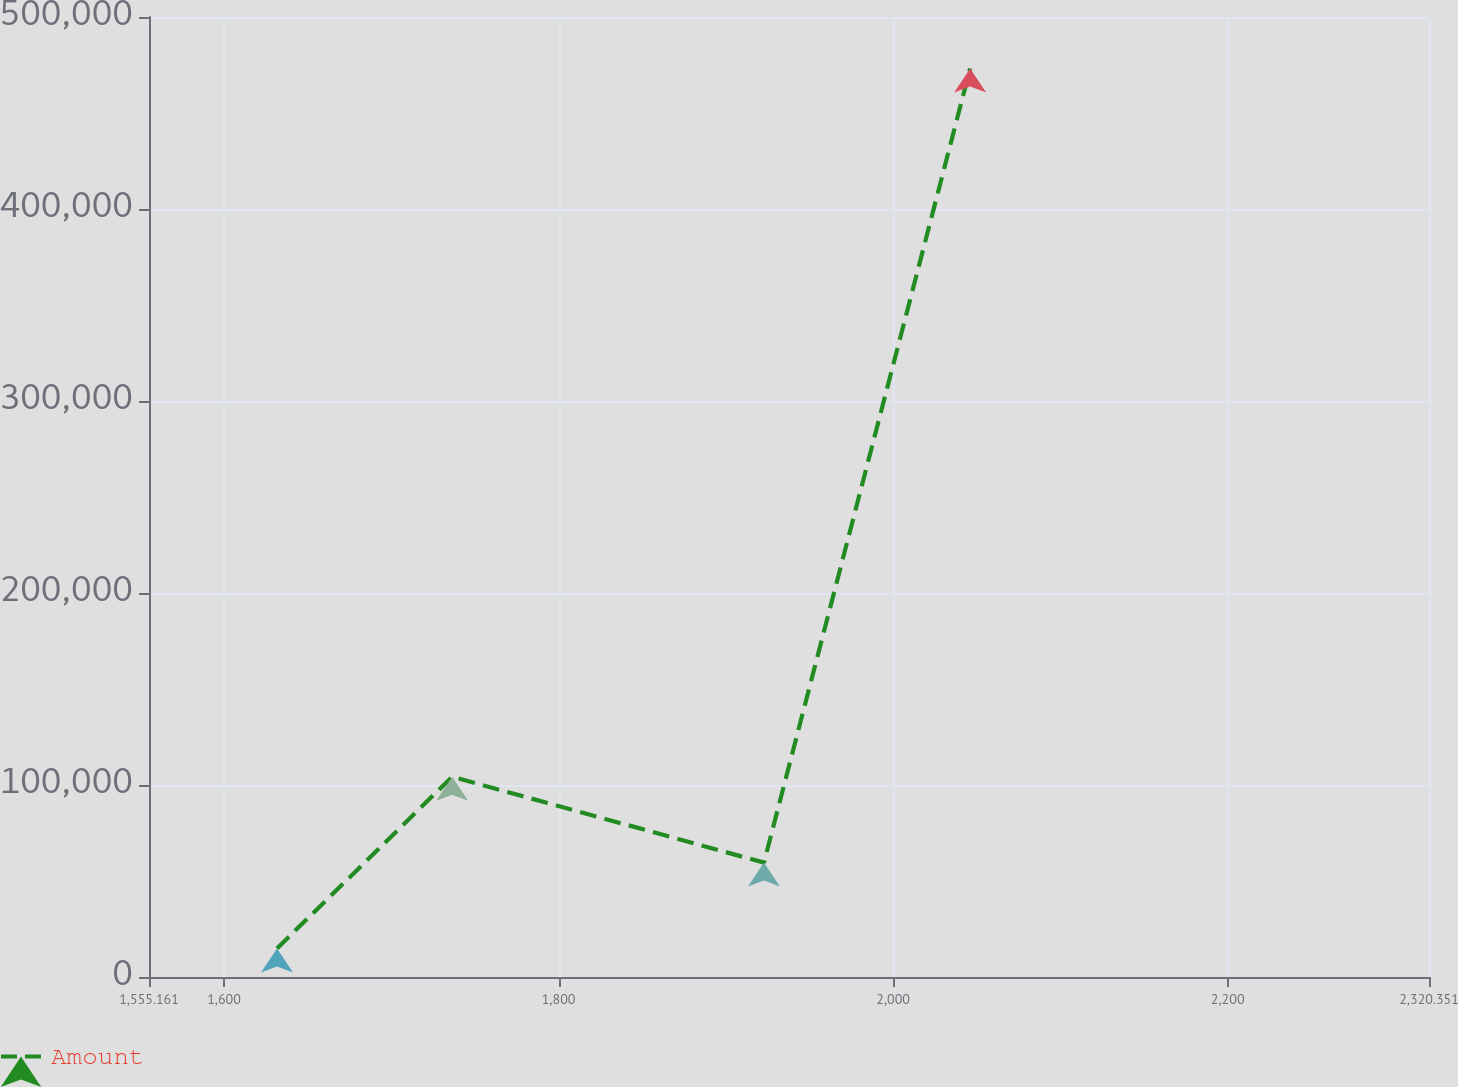Convert chart. <chart><loc_0><loc_0><loc_500><loc_500><line_chart><ecel><fcel>Amount<nl><fcel>1631.68<fcel>14858.5<nl><fcel>1736.41<fcel>104284<nl><fcel>1922.78<fcel>59571.2<nl><fcel>2046.05<fcel>473193<nl><fcel>2396.87<fcel>428480<nl></chart> 